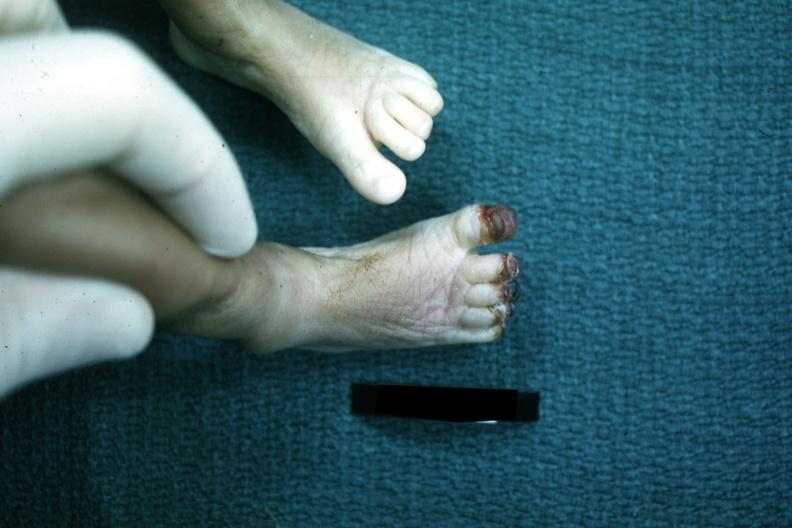re extremities present?
Answer the question using a single word or phrase. Yes 